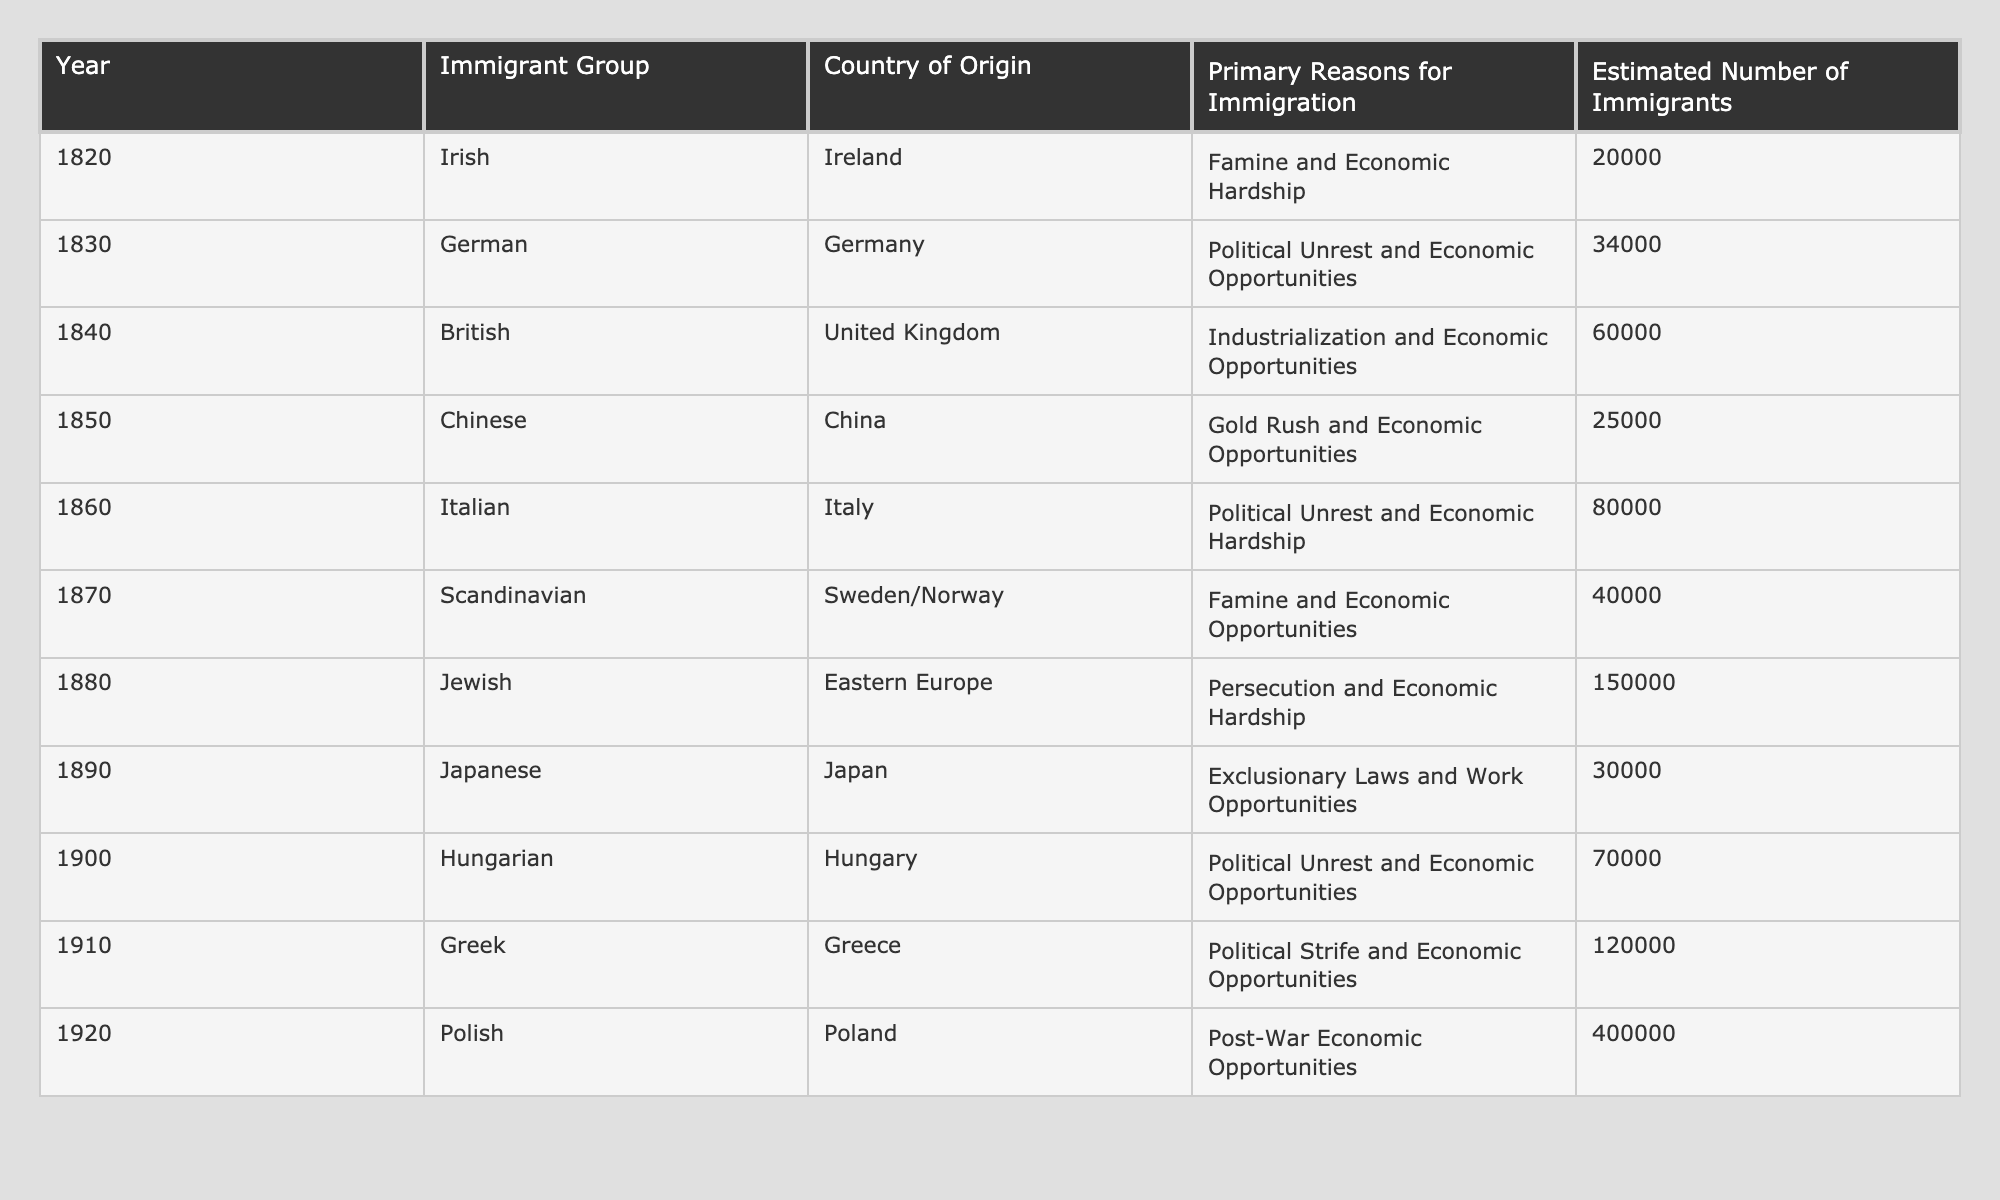What year had the highest estimated number of immigrants? The table shows that in 1920, the estimated number of immigrants was 400,000, which is the highest value in the dataset.
Answer: 1920 How many immigrants came from Italy in 1860? According to the table, 80,000 immigrants came from Italy in 1860.
Answer: 80,000 What was the primary reason for Jewish immigration in 1880? The table indicates that the primary reason for Jewish immigration in 1880 was persecution and economic hardship.
Answer: Persecution and economic hardship What is the total estimated number of immigrants from Germany and Ireland combined in the 1820s and 1830s? From the table, the estimated number of German immigrants in 1830 is 34,000, and Irish immigrants in 1820 is 20,000. Adding these gives 34,000 + 20,000 = 54,000.
Answer: 54,000 Did more immigrants come from Eastern Europe than from China? The table shows that 150,000 Jewish immigrants came from Eastern Europe in 1880, while 25,000 came from China in 1850. Thus, the answer is yes, more immigrants came from Eastern Europe.
Answer: Yes What percentage of the total estimated number of immigrants in 1910 came from Greece? In 1910, there were 120,000 immigrants from Greece. To find the total number of immigrants from 1820 to 1920, we sum all values in the last column, which equals 1,034,000. To find the percentage, we calculate (120,000 / 1,034,000) * 100, which is approximately 11.6%.
Answer: 11.6% What was the trend in immigration from the 1850s to 1900? The estimated number of immigrants steadily increased from 25,000 in 1850 to 70,000 in 1900, indicating a rising trend in immigration during this period.
Answer: Rising trend Which immigrant group experienced political unrest as the primary reason for immigration between 1860 and 1910? The table indicates that both the Italian immigrants in 1860 and the Hungarian immigrants in 1900 cite political unrest as a primary reason, confirming that both experienced political unrest.
Answer: Italian and Hungarian 